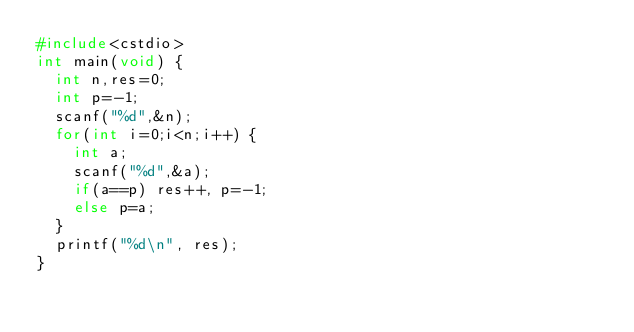<code> <loc_0><loc_0><loc_500><loc_500><_C++_>#include<cstdio>
int main(void) {
  int n,res=0;
  int p=-1;
  scanf("%d",&n);
  for(int i=0;i<n;i++) {
    int a;
    scanf("%d",&a);
    if(a==p) res++, p=-1;
    else p=a;
  }
  printf("%d\n", res);
}</code> 